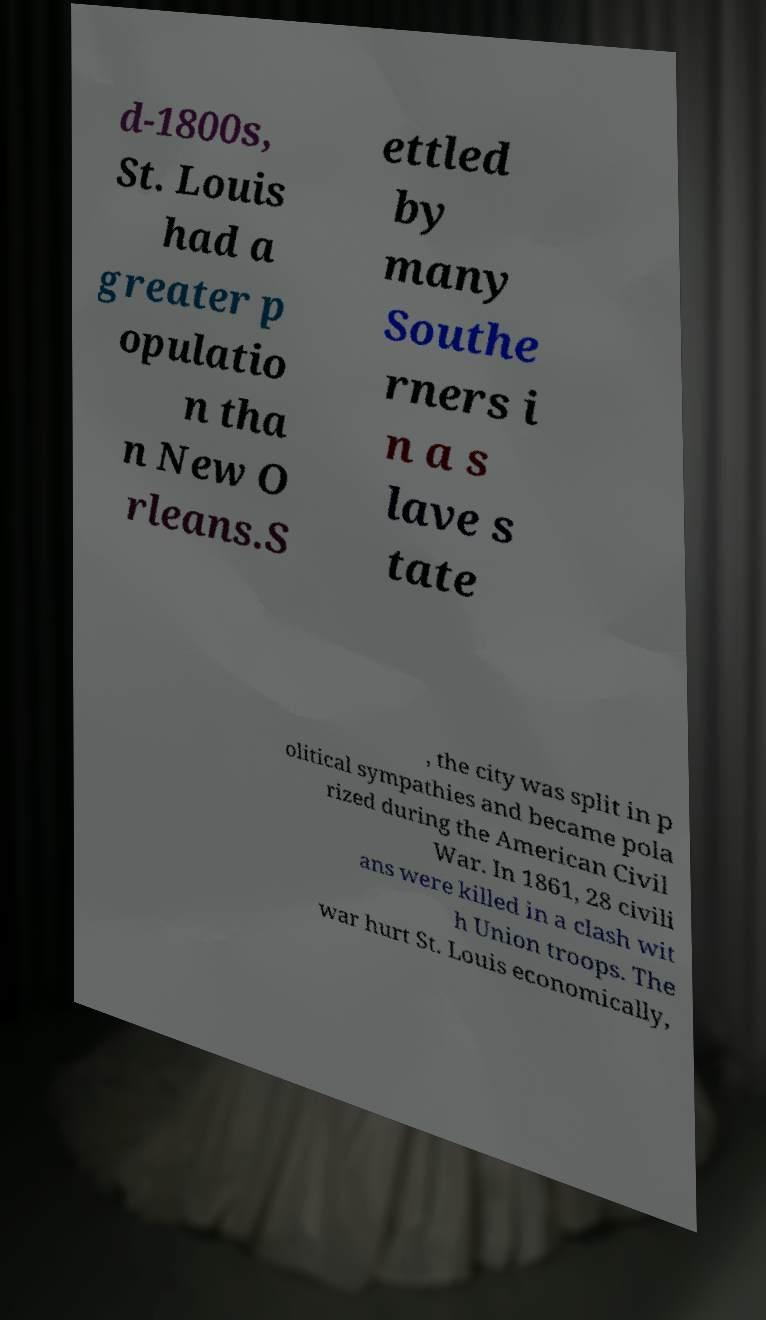Can you accurately transcribe the text from the provided image for me? d-1800s, St. Louis had a greater p opulatio n tha n New O rleans.S ettled by many Southe rners i n a s lave s tate , the city was split in p olitical sympathies and became pola rized during the American Civil War. In 1861, 28 civili ans were killed in a clash wit h Union troops. The war hurt St. Louis economically, 